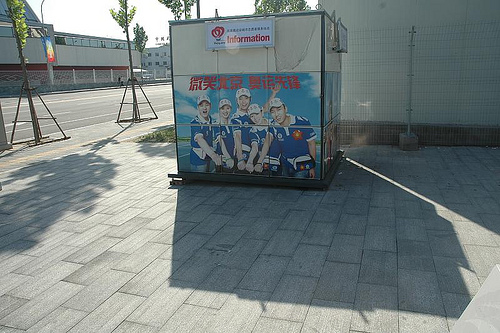<image>
Is the road in front of the tree? No. The road is not in front of the tree. The spatial positioning shows a different relationship between these objects. 